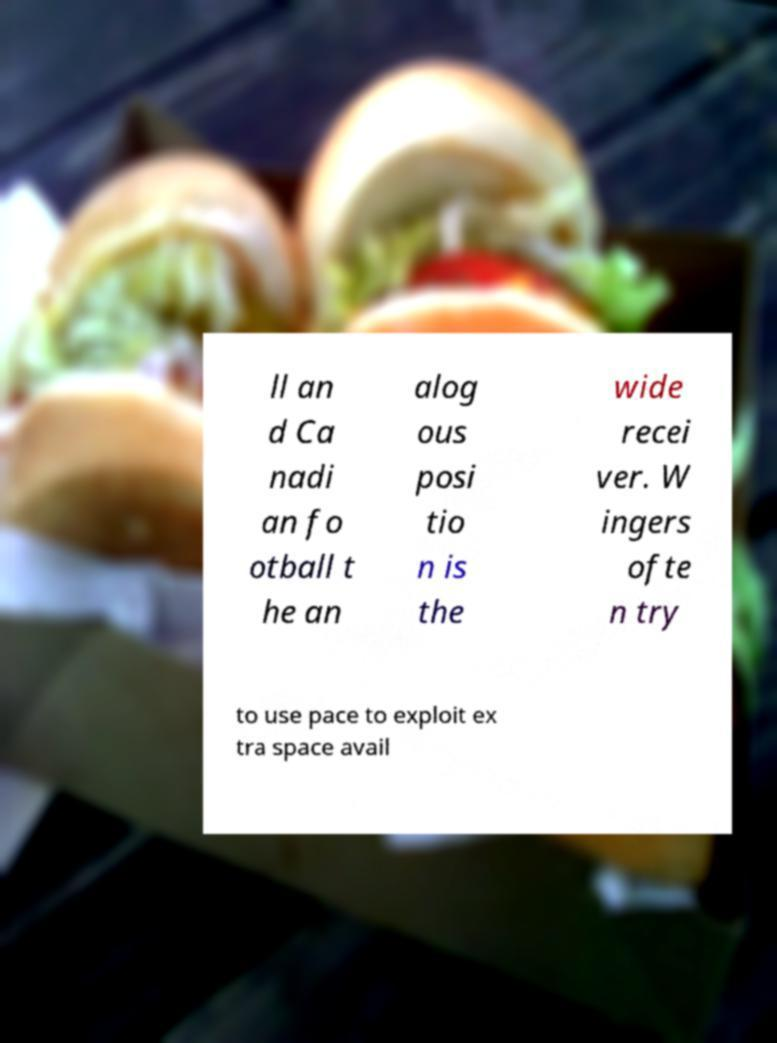Can you accurately transcribe the text from the provided image for me? ll an d Ca nadi an fo otball t he an alog ous posi tio n is the wide recei ver. W ingers ofte n try to use pace to exploit ex tra space avail 